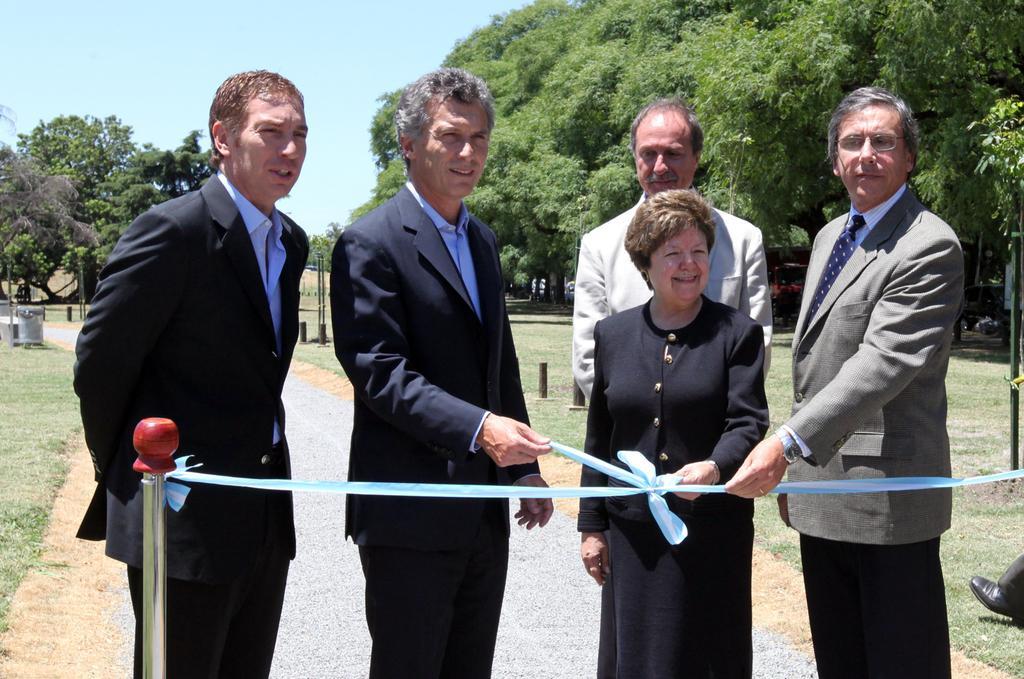Could you give a brief overview of what you see in this image? In the center of the image we can see a few people are standing and they are smiling and they are in different costumes. Among them, we can see a few people are holding a ribbon, which is attached to the pole. On the right side of the image, there is a shoe and cloth. In the background, we can see the sky, trees, grass, poles and a few other objects. 